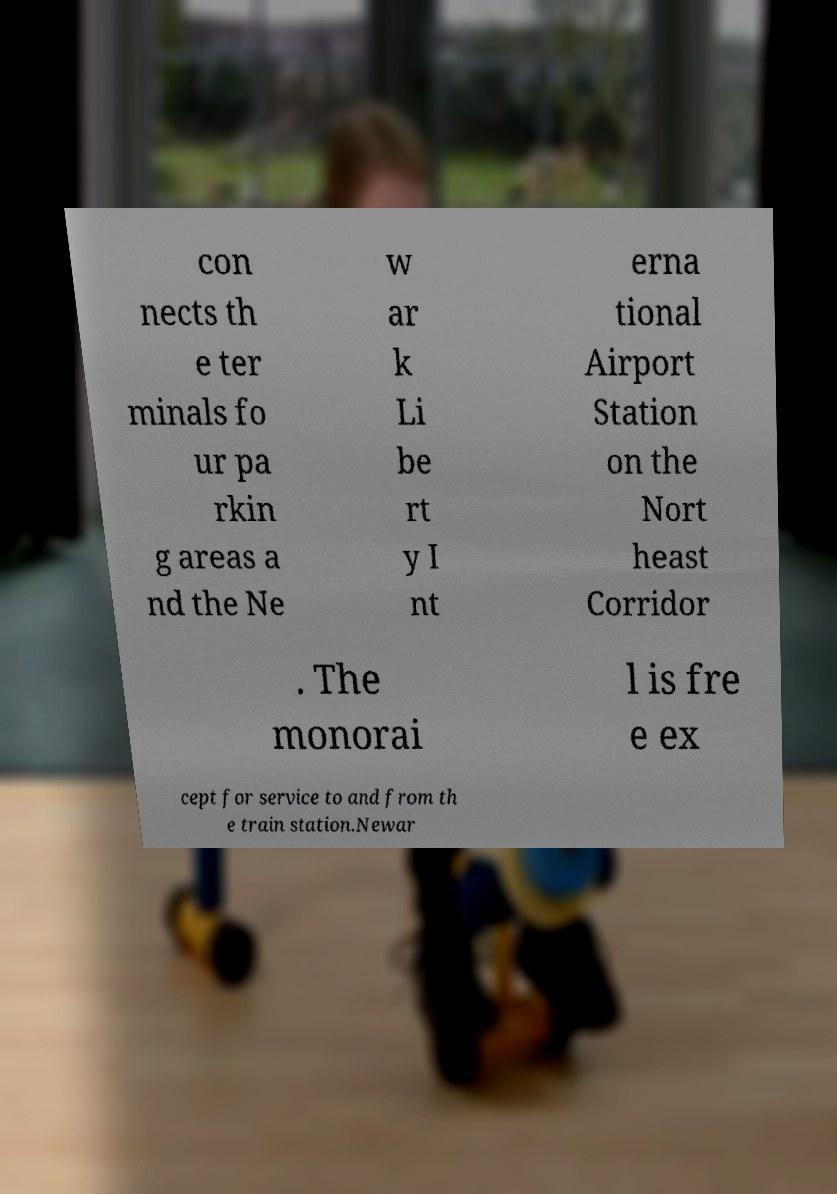Please identify and transcribe the text found in this image. con nects th e ter minals fo ur pa rkin g areas a nd the Ne w ar k Li be rt y I nt erna tional Airport Station on the Nort heast Corridor . The monorai l is fre e ex cept for service to and from th e train station.Newar 